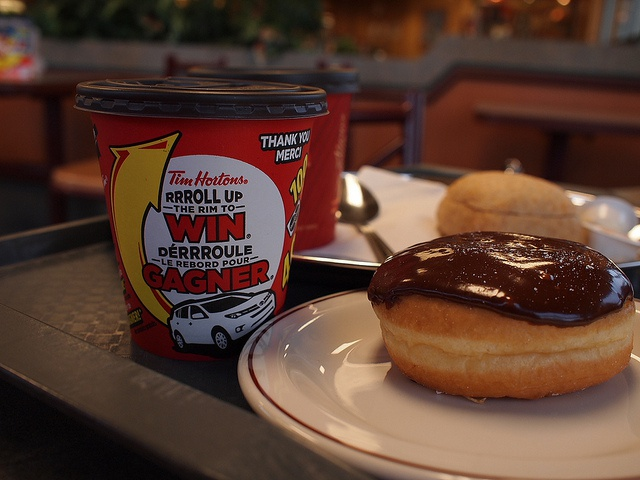Describe the objects in this image and their specific colors. I can see cup in tan, black, maroon, gray, and olive tones, donut in tan, brown, black, maroon, and gray tones, cup in tan, maroon, black, and brown tones, donut in tan, brown, and gray tones, and spoon in tan, maroon, ivory, and black tones in this image. 